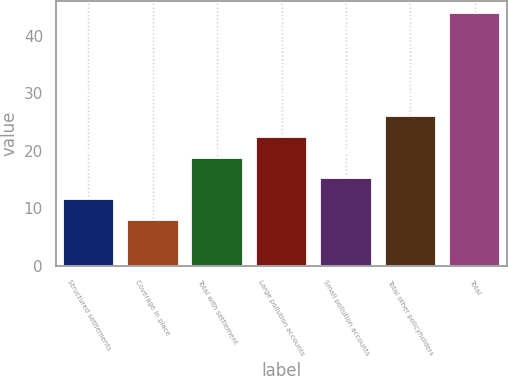<chart> <loc_0><loc_0><loc_500><loc_500><bar_chart><fcel>Structured settlements<fcel>Coverage in place<fcel>Total with settlement<fcel>Large pollution accounts<fcel>Small pollution accounts<fcel>Total other policyholders<fcel>Total<nl><fcel>11.6<fcel>8<fcel>18.8<fcel>22.4<fcel>15.2<fcel>26<fcel>44<nl></chart> 